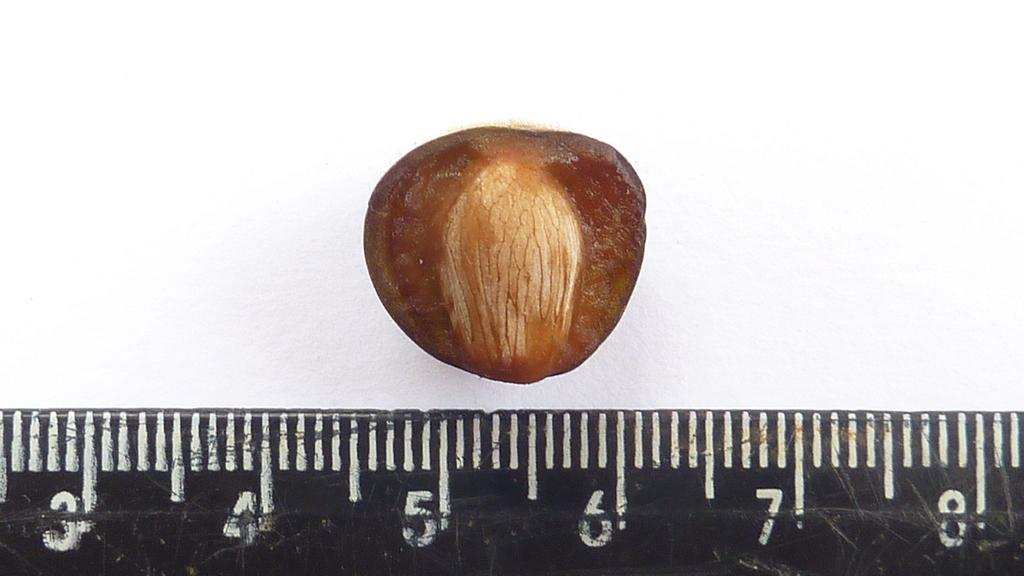Provide a one-sentence caption for the provided image. The nut shown measures from 4.5 to 6 centimetres. 